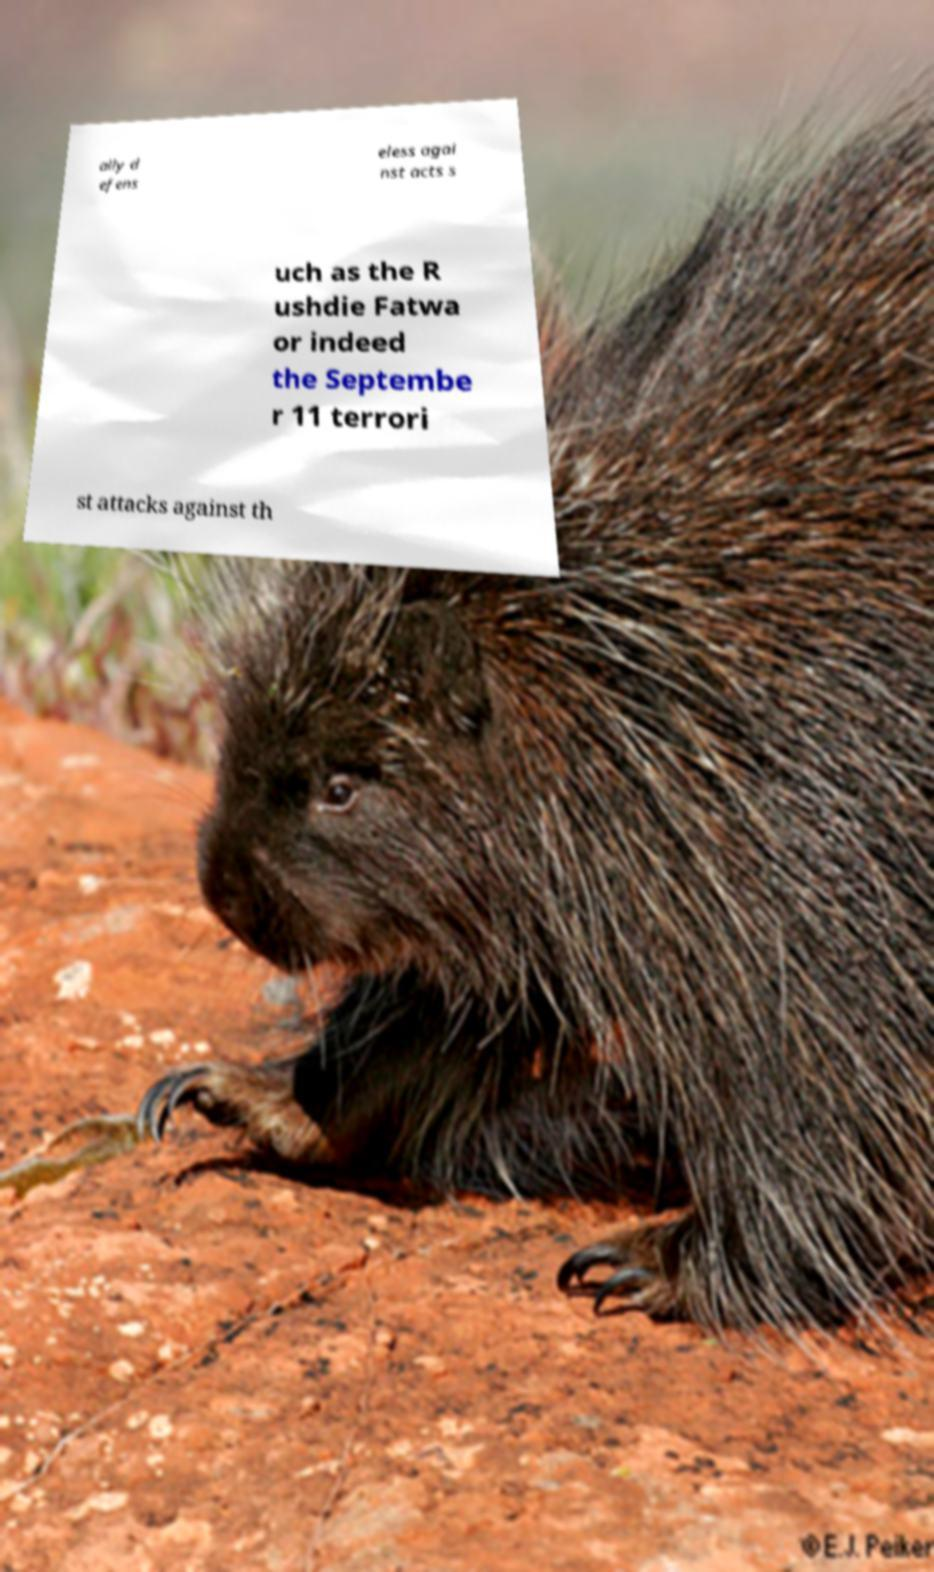Could you assist in decoding the text presented in this image and type it out clearly? ally d efens eless agai nst acts s uch as the R ushdie Fatwa or indeed the Septembe r 11 terrori st attacks against th 